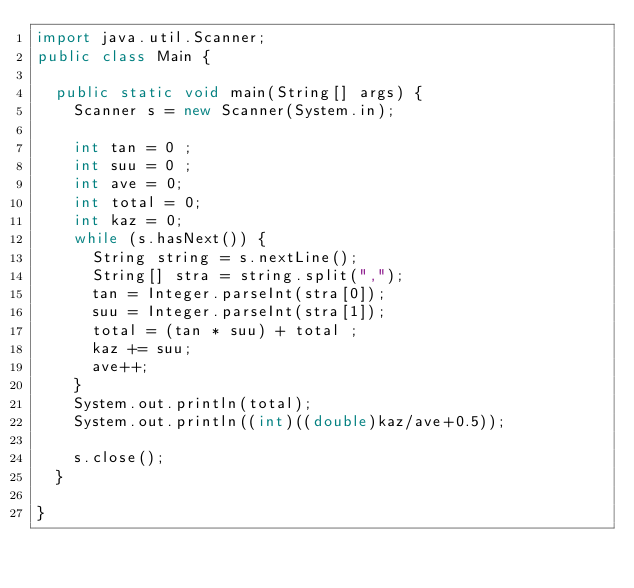<code> <loc_0><loc_0><loc_500><loc_500><_Java_>import java.util.Scanner;
public class Main {

	public static void main(String[] args) {
		Scanner s = new Scanner(System.in);
		
		int tan = 0 ;
		int suu = 0 ;
		int ave = 0;
		int total = 0;
		int kaz = 0;
		while (s.hasNext()) {
			String string = s.nextLine();
			String[] stra = string.split(",");
			tan = Integer.parseInt(stra[0]);
			suu = Integer.parseInt(stra[1]);
			total = (tan * suu) + total ; 
			kaz += suu;
			ave++;			
		}
		System.out.println(total);
		System.out.println((int)((double)kaz/ave+0.5));
		
		s.close();
	}

}</code> 